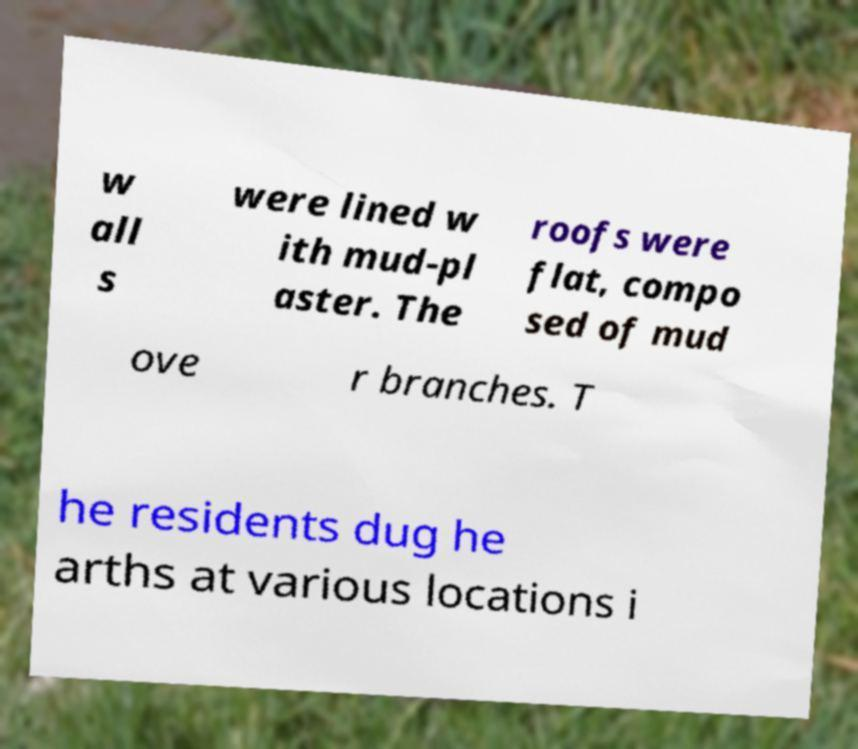Can you accurately transcribe the text from the provided image for me? w all s were lined w ith mud-pl aster. The roofs were flat, compo sed of mud ove r branches. T he residents dug he arths at various locations i 